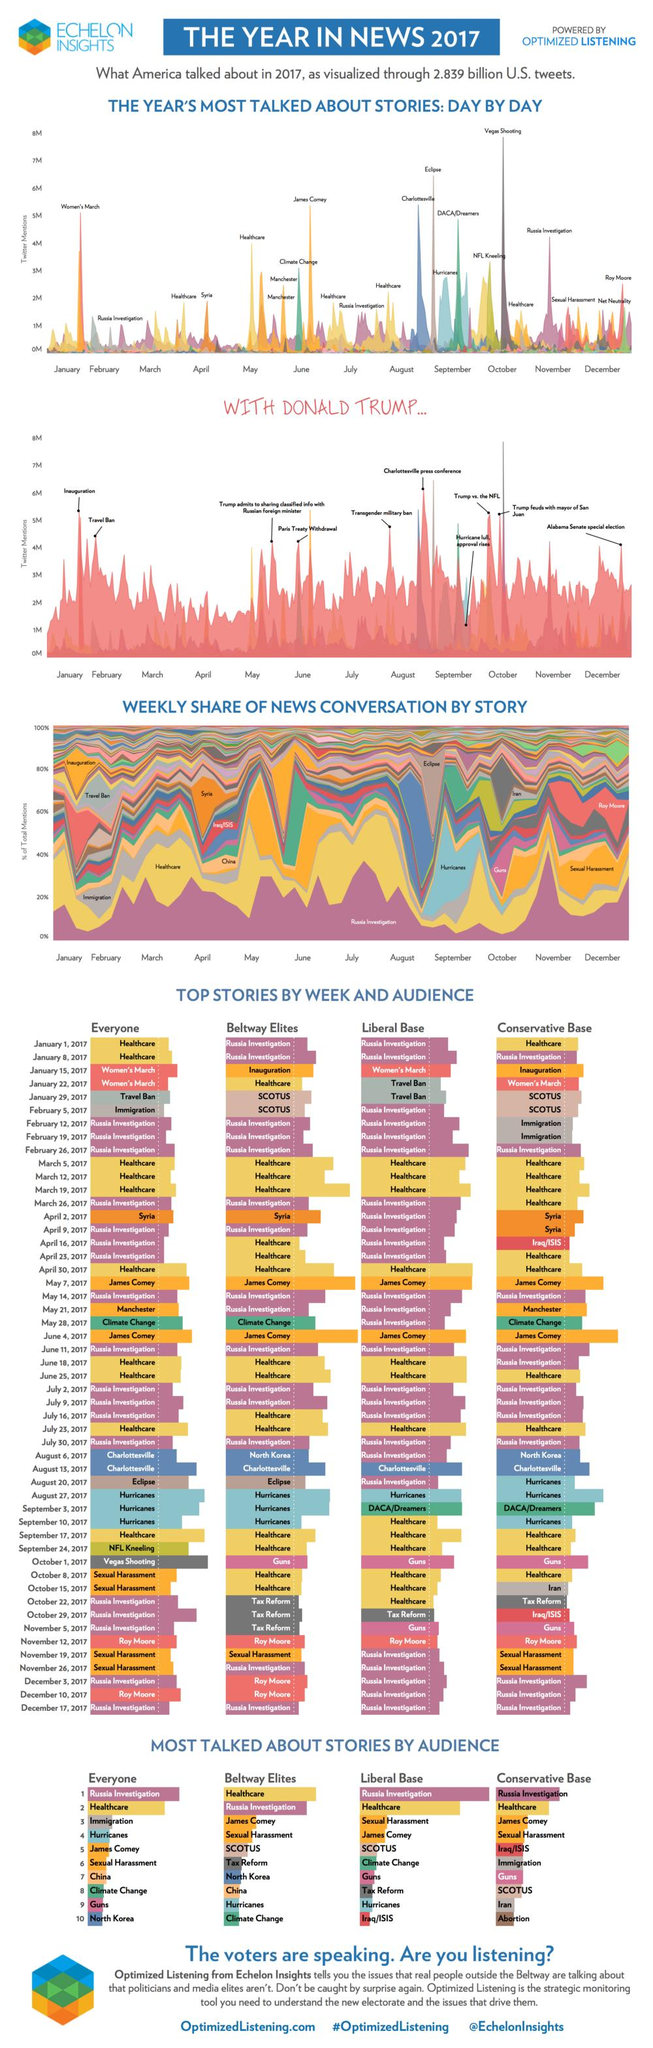Specify some key components in this picture. The Vegas shooting was most widely talked about during the month of October. In November 2017, the story about the Russia investigation was the most talked about. 